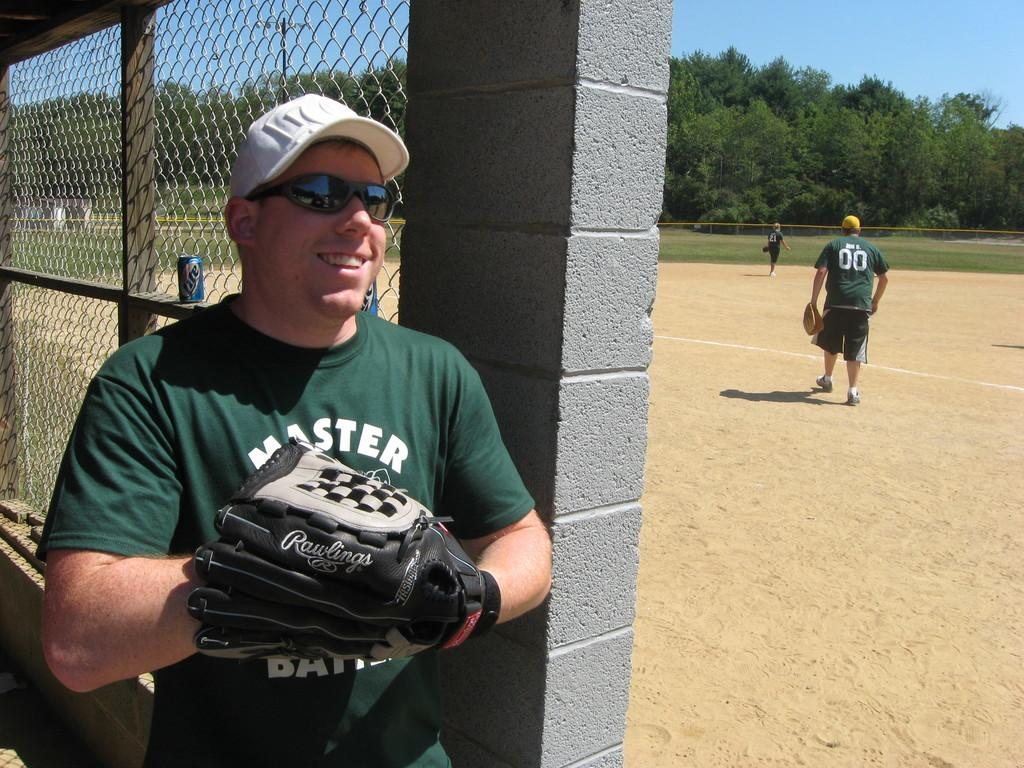Provide a one-sentence caption for the provided image. a guy with a white hat that is holding a glove and a Master shirt. 